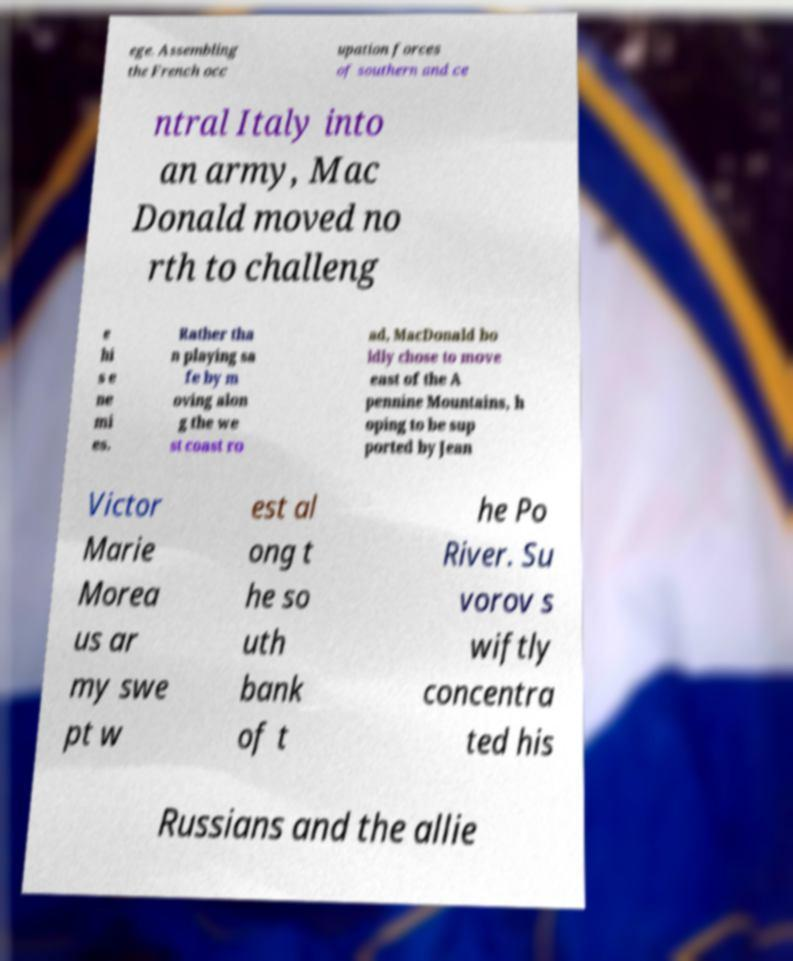There's text embedded in this image that I need extracted. Can you transcribe it verbatim? ege. Assembling the French occ upation forces of southern and ce ntral Italy into an army, Mac Donald moved no rth to challeng e hi s e ne mi es. Rather tha n playing sa fe by m oving alon g the we st coast ro ad, MacDonald bo ldly chose to move east of the A pennine Mountains, h oping to be sup ported by Jean Victor Marie Morea us ar my swe pt w est al ong t he so uth bank of t he Po River. Su vorov s wiftly concentra ted his Russians and the allie 